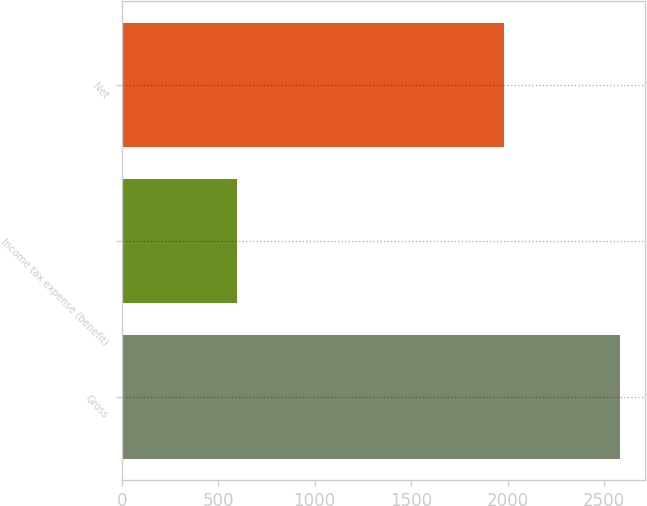<chart> <loc_0><loc_0><loc_500><loc_500><bar_chart><fcel>Gross<fcel>Income tax expense (benefit)<fcel>Net<nl><fcel>2581<fcel>599<fcel>1982<nl></chart> 